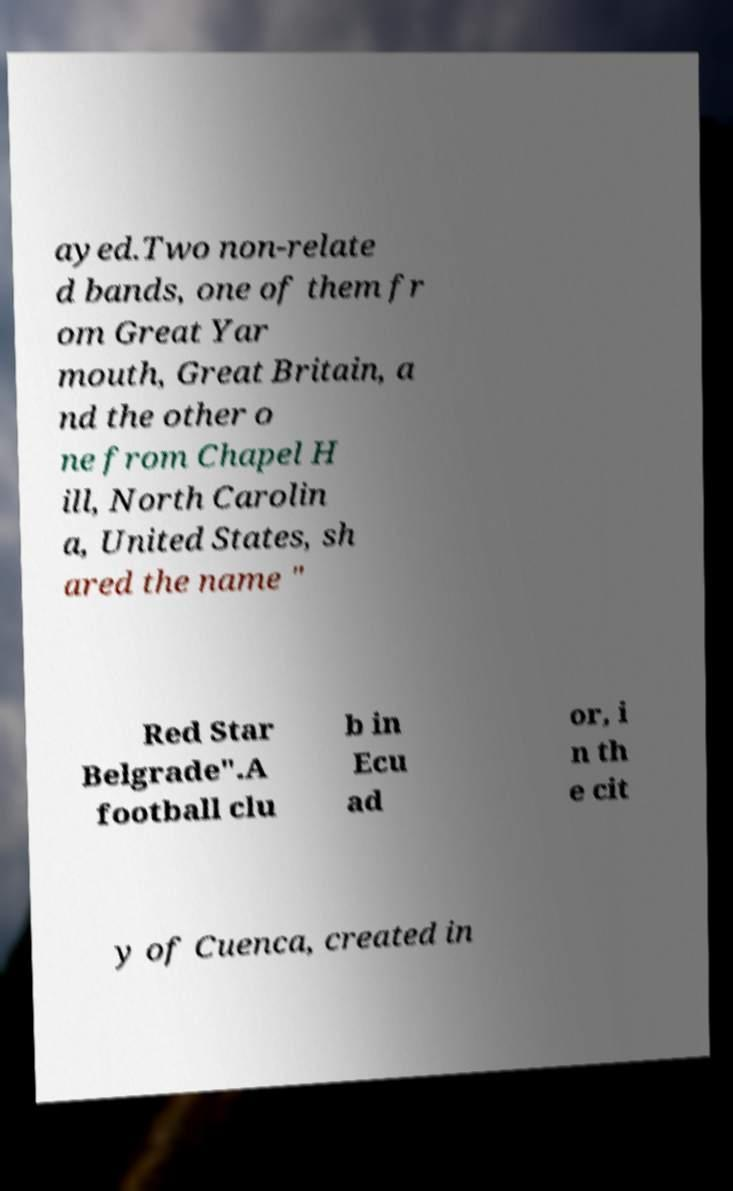I need the written content from this picture converted into text. Can you do that? ayed.Two non-relate d bands, one of them fr om Great Yar mouth, Great Britain, a nd the other o ne from Chapel H ill, North Carolin a, United States, sh ared the name " Red Star Belgrade".A football clu b in Ecu ad or, i n th e cit y of Cuenca, created in 